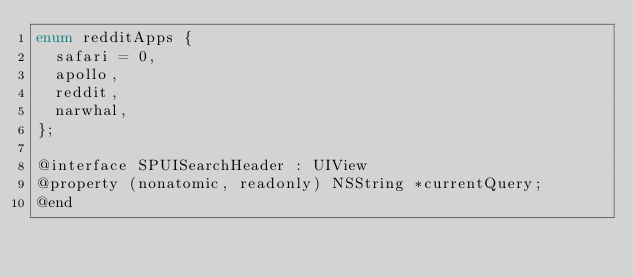<code> <loc_0><loc_0><loc_500><loc_500><_C_>enum redditApps {
  safari = 0,
  apollo,
  reddit,
  narwhal,
};

@interface SPUISearchHeader : UIView
@property (nonatomic, readonly) NSString *currentQuery;
@end
</code> 